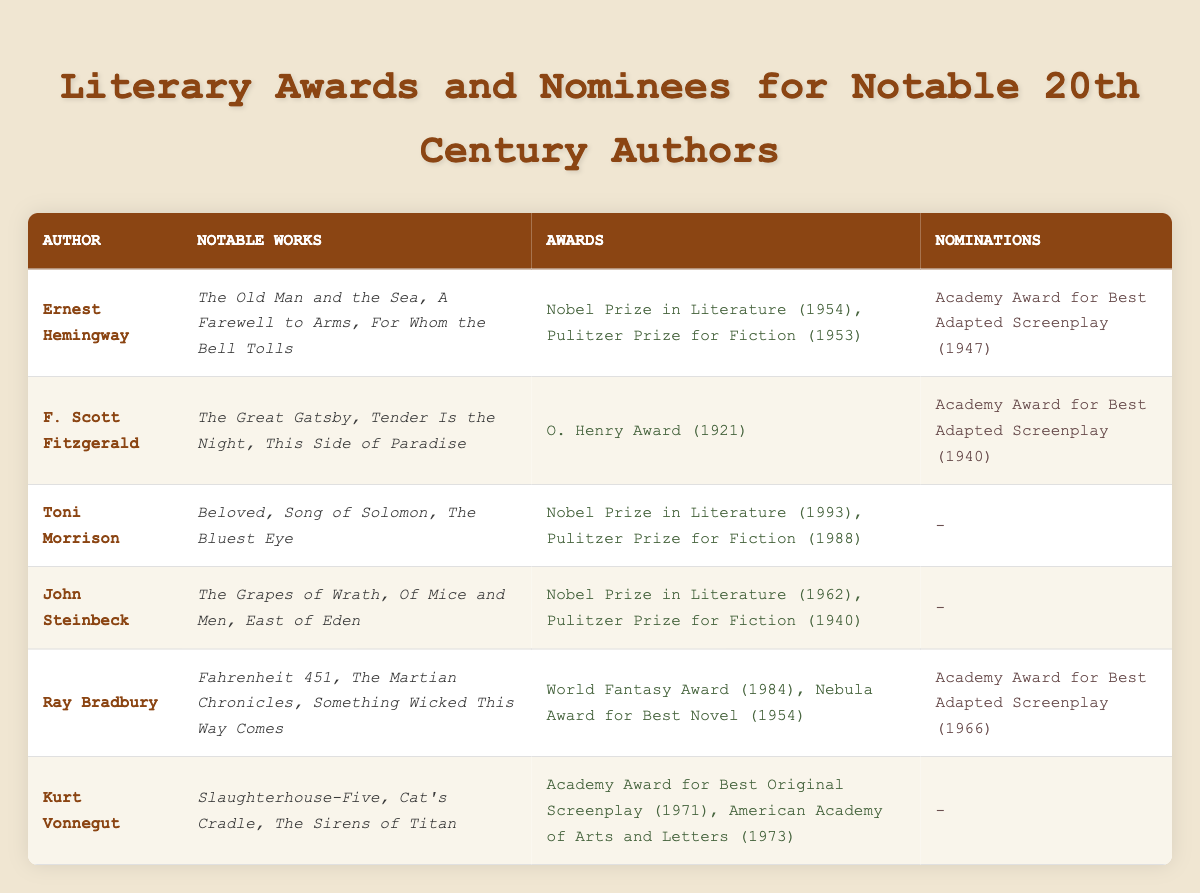What awards did Ernest Hemingway win? Ernest Hemingway won the Nobel Prize in Literature in 1954 and the Pulitzer Prize for Fiction in 1953, as listed under his awards.
Answer: Nobel Prize in Literature (1954), Pulitzer Prize for Fiction (1953) How many notable works are listed for Toni Morrison? The table shows that Toni Morrison has three notable works: "Beloved," "Song of Solomon," and "The Bluest Eye."
Answer: 3 Did F. Scott Fitzgerald receive any nominations for awards? The table mentions that F. Scott Fitzgerald was nominated for the Academy Award for Best Adapted Screenplay in 1940, indicating that he did indeed receive a nomination.
Answer: Yes What is the total number of Academy Award nominations for all authors listed? Ernest Hemingway, F. Scott Fitzgerald, and Ray Bradbury each have one Academy Award nomination, giving a total of three nominations across those three authors. Toni Morrison, John Steinbeck, and Kurt Vonnegut have no nominations, resulting in a total of three Academy Award nominations.
Answer: 3 Which author has the most recent Nobel Prize in Literature? The table indicates that Toni Morrison received the Nobel Prize in Literature in 1993, which is the latest date listed in the awards section.
Answer: Toni Morrison List the authors who received the Pulitzer Prize for Fiction. The table shows that Ernest Hemingway, Toni Morrison, and John Steinbeck all received the Pulitzer Prize for Fiction, indicating that all three authors listed had this award.
Answer: Ernest Hemingway, Toni Morrison, John Steinbeck Which author has the most notable works mentioned? The table lists three notable works for each of the authors; thus, no author has more notable works than the others, as all have three notable works mentioned.
Answer: None, all have three How many authors in the table have not received any award nominations? John Steinbeck, Toni Morrison, and Kurt Vonnegut have no listed nominations, while others do. Counting these gives three authors without nominations.
Answer: 3 What is the difference in years between the first and last Nobel Prize winners listed? Ernest Hemingway won the Nobel Prize in Literature in 1954, while Toni Morrison won it in 1993. Subtracting these years (1993 - 1954) gives a difference of 39 years.
Answer: 39 years What percentage of the authors have received both a Nobel Prize and a Pulitzer Prize? There are six authors, and only three of them (Toni Morrison, John Steinbeck, and Ernest Hemingway) have received both prizes. This gives (3/6) * 100 = 50%.
Answer: 50% 